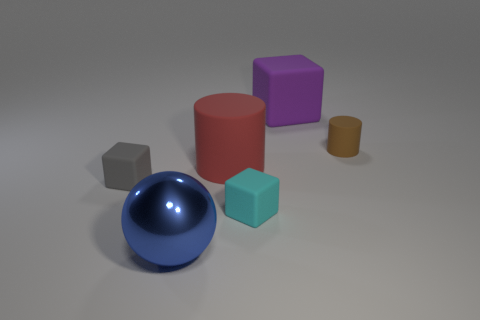Subtract all big rubber blocks. How many blocks are left? 2 Add 2 tiny red matte cylinders. How many objects exist? 8 Subtract all purple cubes. How many cubes are left? 2 Subtract 1 spheres. How many spheres are left? 0 Subtract all green blocks. How many brown cylinders are left? 1 Subtract 0 cyan cylinders. How many objects are left? 6 Subtract all cylinders. How many objects are left? 4 Subtract all purple cylinders. Subtract all gray cubes. How many cylinders are left? 2 Subtract all large purple matte cylinders. Subtract all tiny brown rubber things. How many objects are left? 5 Add 4 gray cubes. How many gray cubes are left? 5 